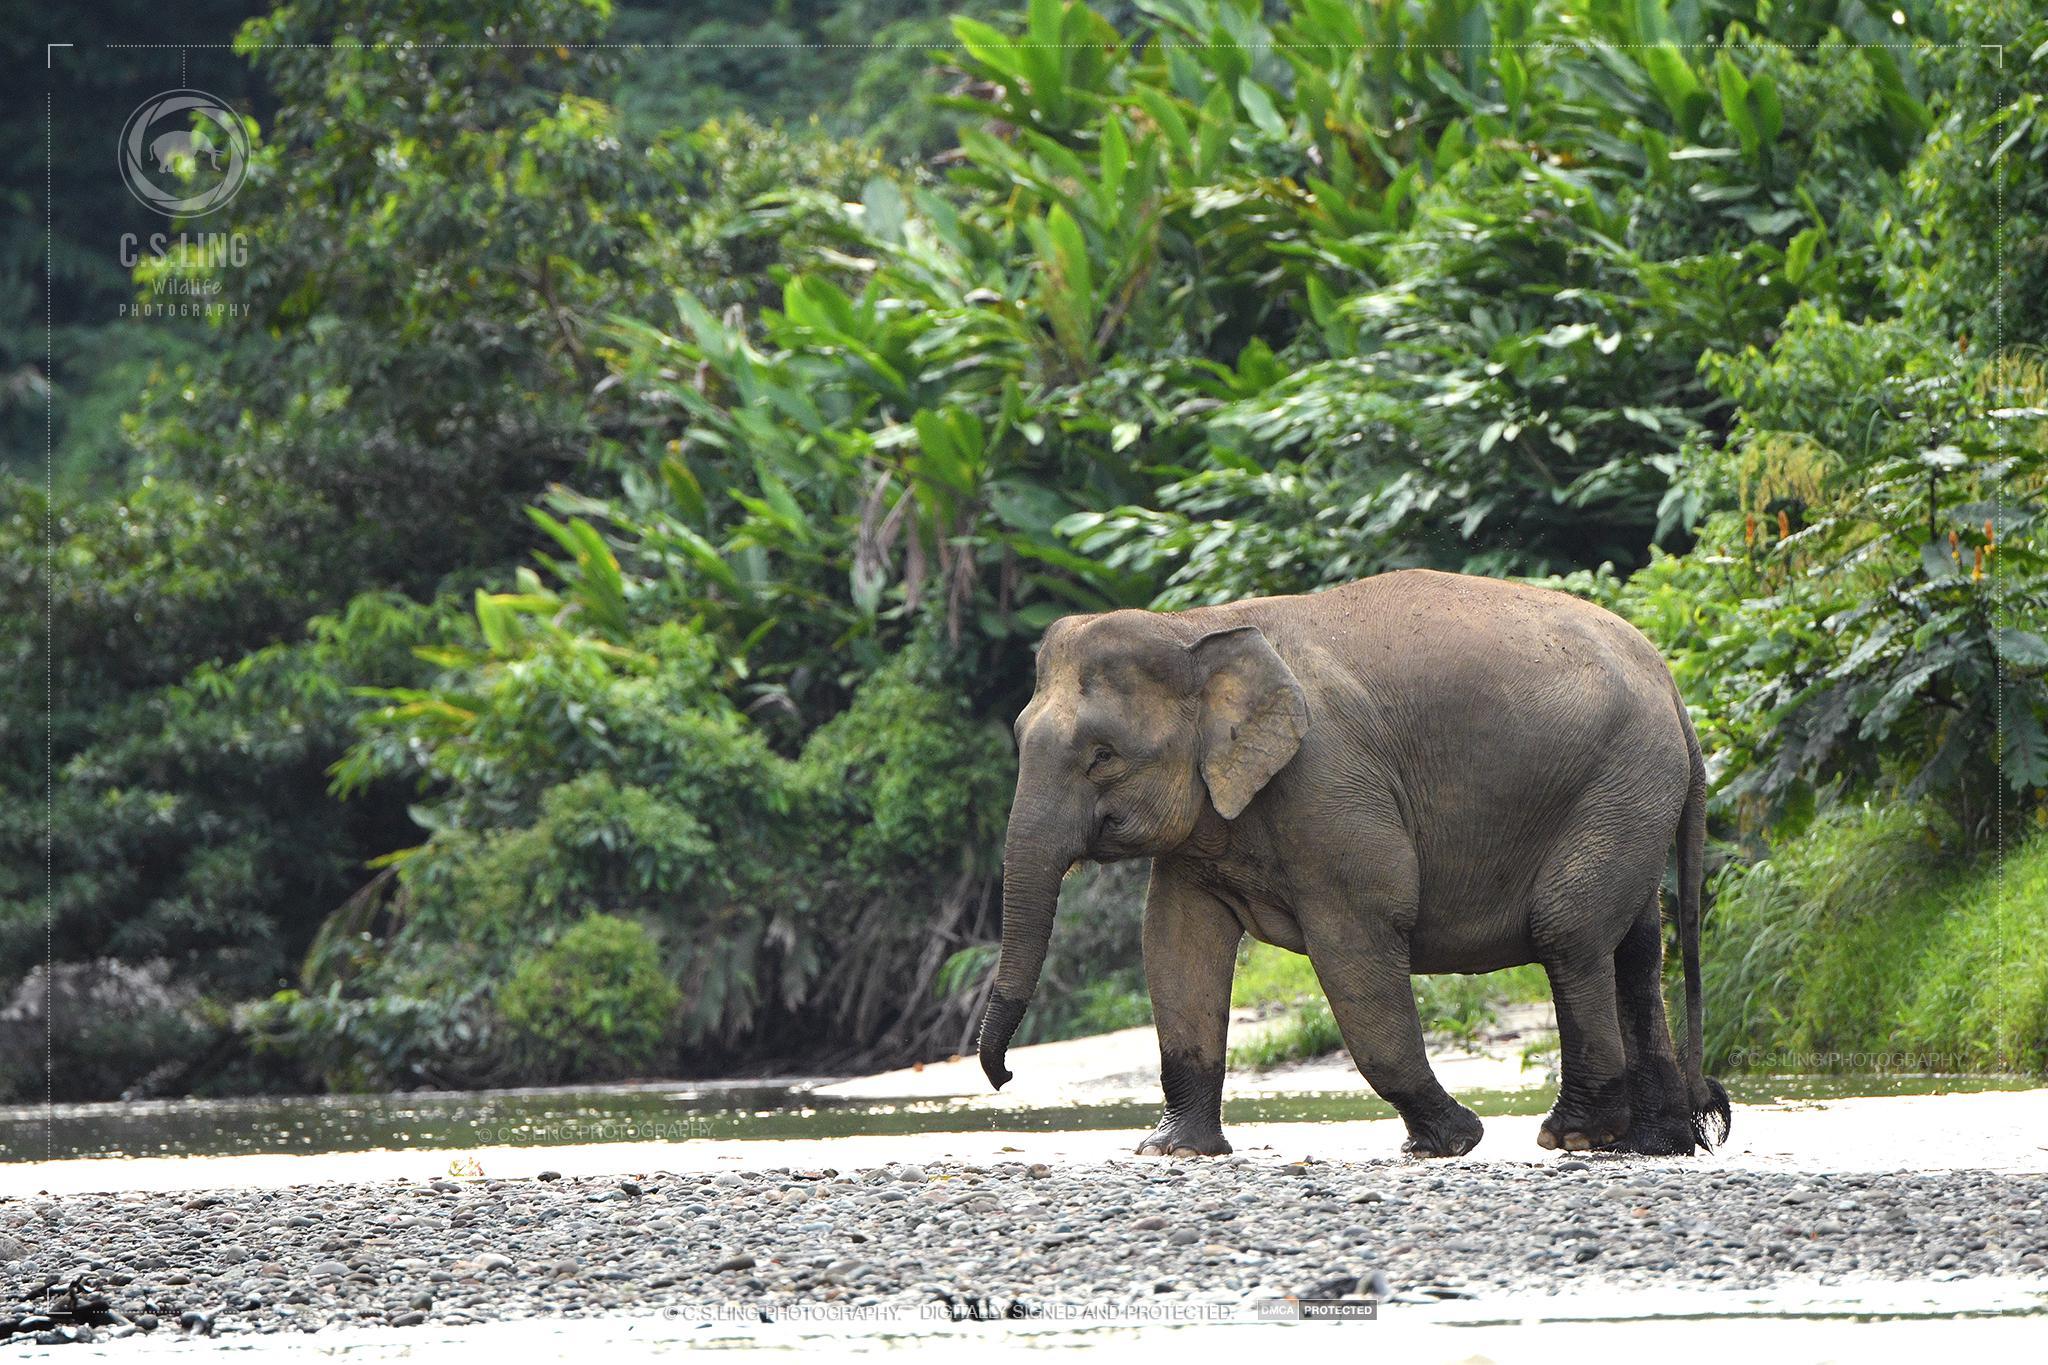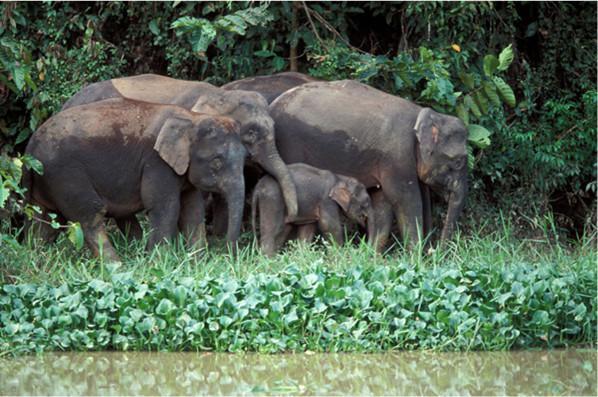The first image is the image on the left, the second image is the image on the right. Given the left and right images, does the statement "One image has only one elephant in it." hold true? Answer yes or no. Yes. 